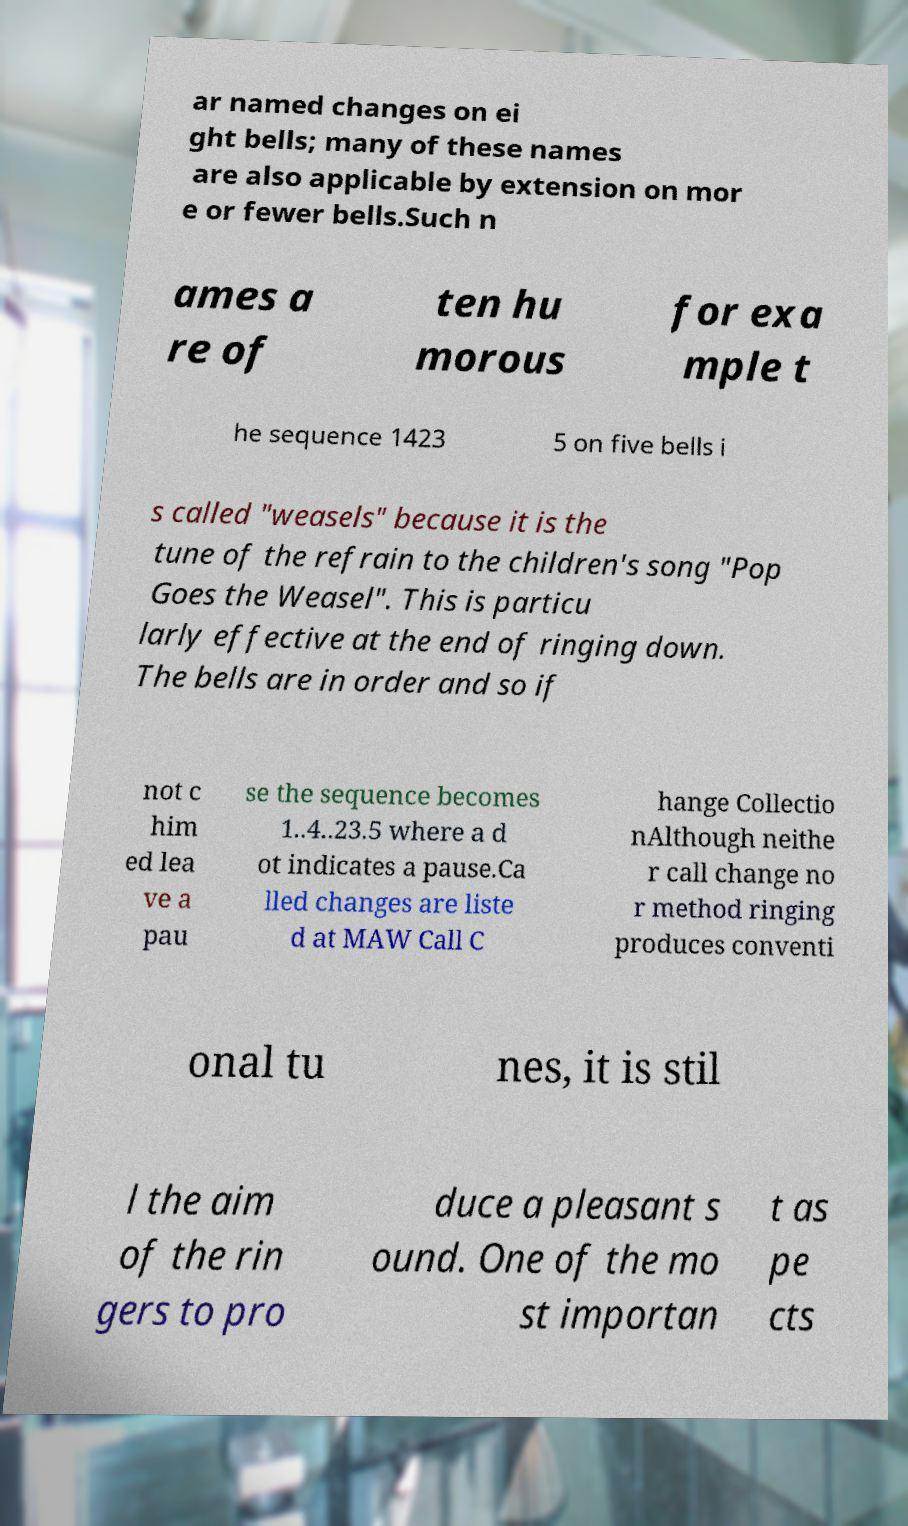Please read and relay the text visible in this image. What does it say? ar named changes on ei ght bells; many of these names are also applicable by extension on mor e or fewer bells.Such n ames a re of ten hu morous for exa mple t he sequence 1423 5 on five bells i s called "weasels" because it is the tune of the refrain to the children's song "Pop Goes the Weasel". This is particu larly effective at the end of ringing down. The bells are in order and so if not c him ed lea ve a pau se the sequence becomes 1..4..23.5 where a d ot indicates a pause.Ca lled changes are liste d at MAW Call C hange Collectio nAlthough neithe r call change no r method ringing produces conventi onal tu nes, it is stil l the aim of the rin gers to pro duce a pleasant s ound. One of the mo st importan t as pe cts 